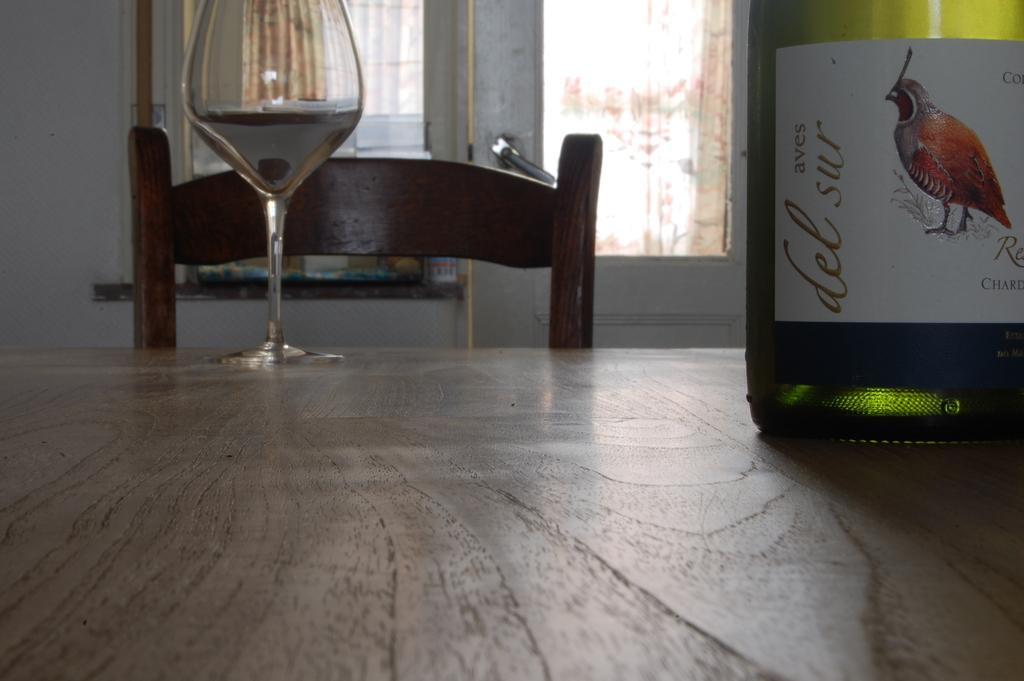What is on the table in the image? There is a wine glass on the table. What else can be seen related to wine in the image? There is a wine bottle in the image. What architectural features are visible in the background of the image? There is a door and a window in the background of the image. What type of orange can be seen causing a rhythmic disturbance in the image? There is no orange present in the image, and therefore no such disturbance can be observed. 